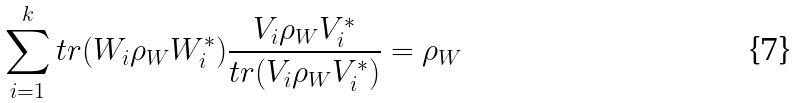Convert formula to latex. <formula><loc_0><loc_0><loc_500><loc_500>\sum _ { i = 1 } ^ { k } t r ( W _ { i } \rho _ { W } W _ { i } ^ { * } ) \frac { V _ { i } \rho _ { W } V _ { i } ^ { * } } { t r ( V _ { i } \rho _ { W } V _ { i } ^ { * } ) } = \rho _ { W }</formula> 